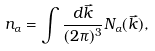<formula> <loc_0><loc_0><loc_500><loc_500>n _ { \alpha } = \int \frac { d \vec { k } } { ( 2 \pi ) ^ { 3 } } N _ { \alpha } ( \vec { k } ) ,</formula> 